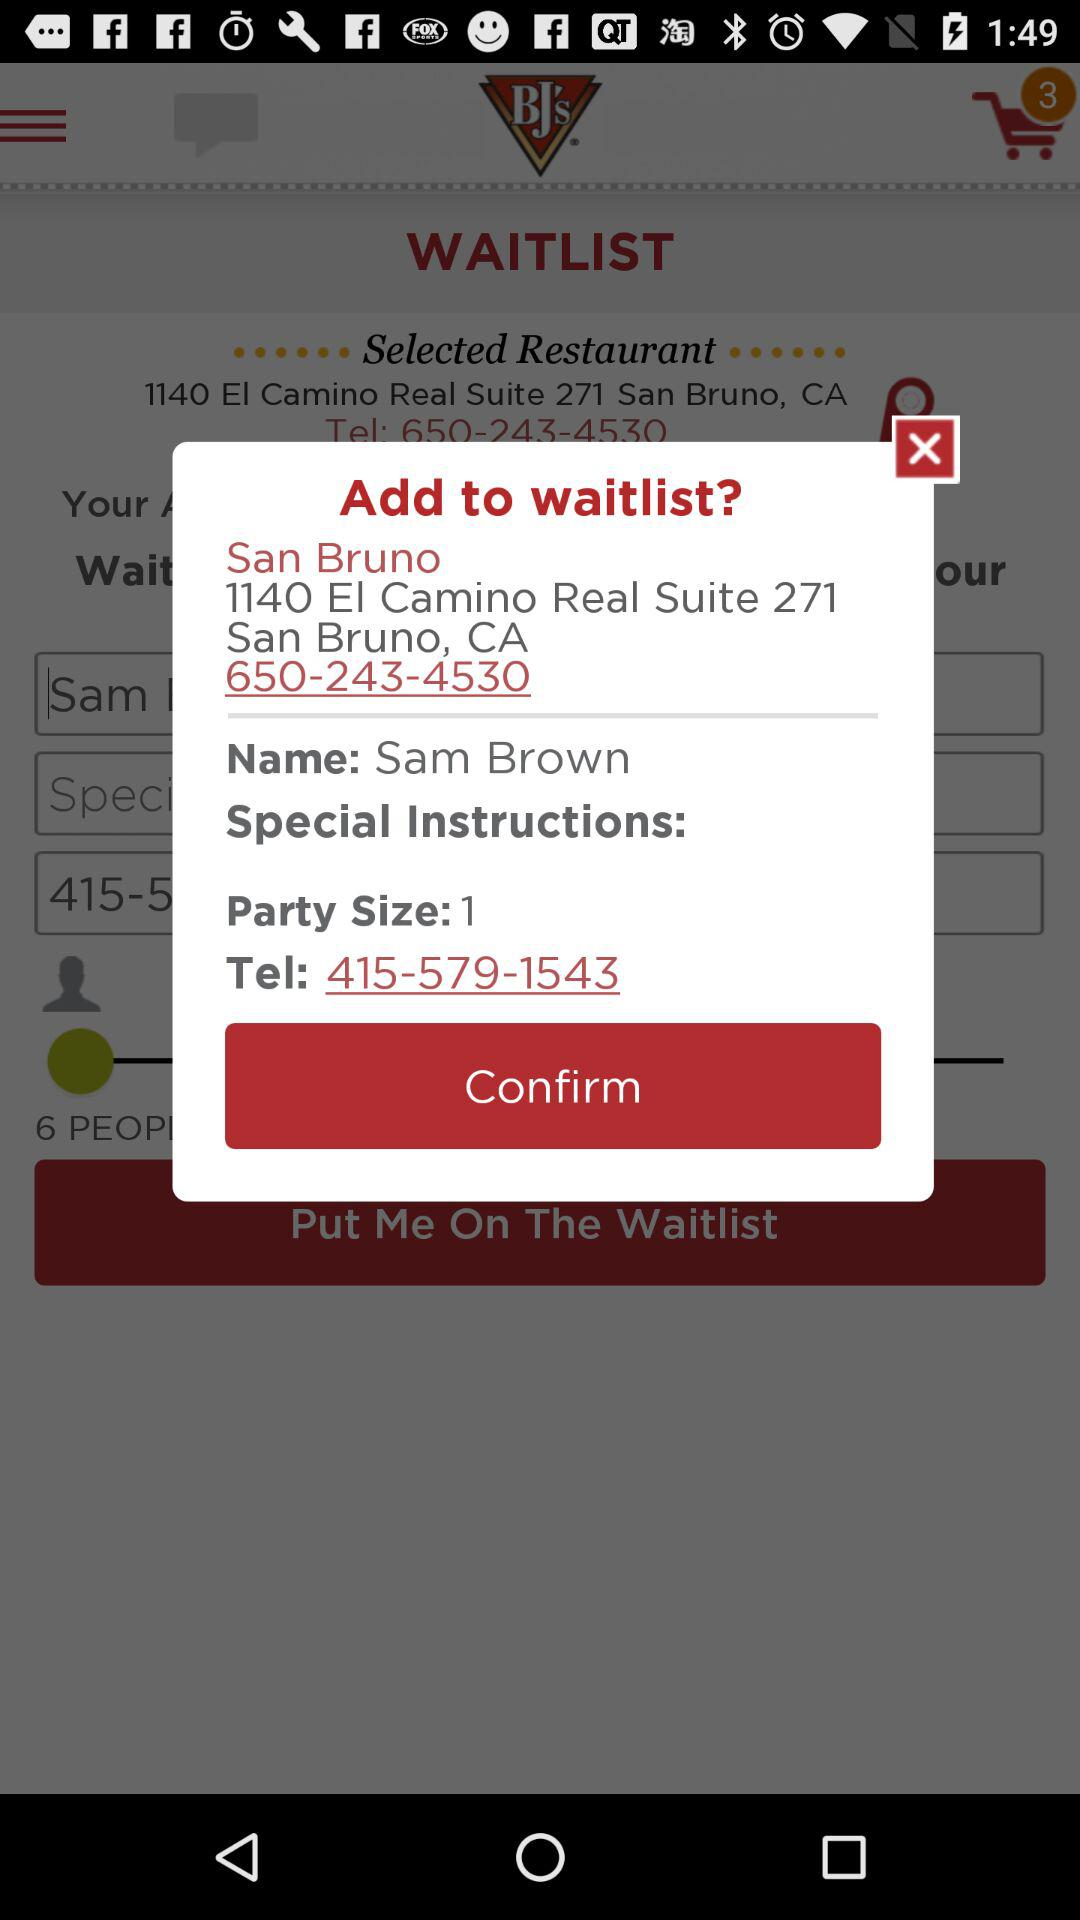What is the party size? The party size is 1. 